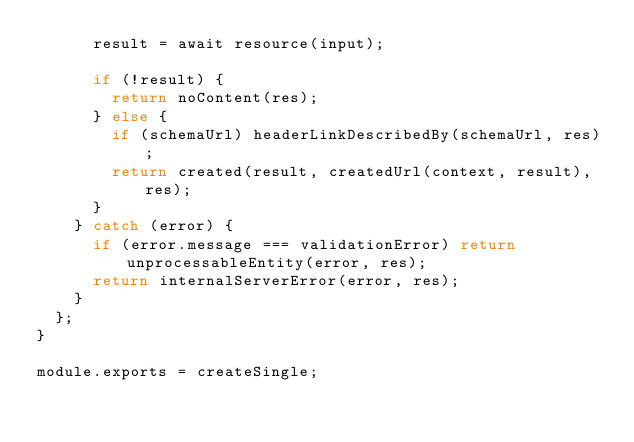Convert code to text. <code><loc_0><loc_0><loc_500><loc_500><_JavaScript_>      result = await resource(input);
  
      if (!result) {
        return noContent(res);
      } else {
        if (schemaUrl) headerLinkDescribedBy(schemaUrl, res);
        return created(result, createdUrl(context, result), res);
      }
    } catch (error) {
      if (error.message === validationError) return unprocessableEntity(error, res);
      return internalServerError(error, res);
    }
  };
}

module.exports = createSingle;
</code> 